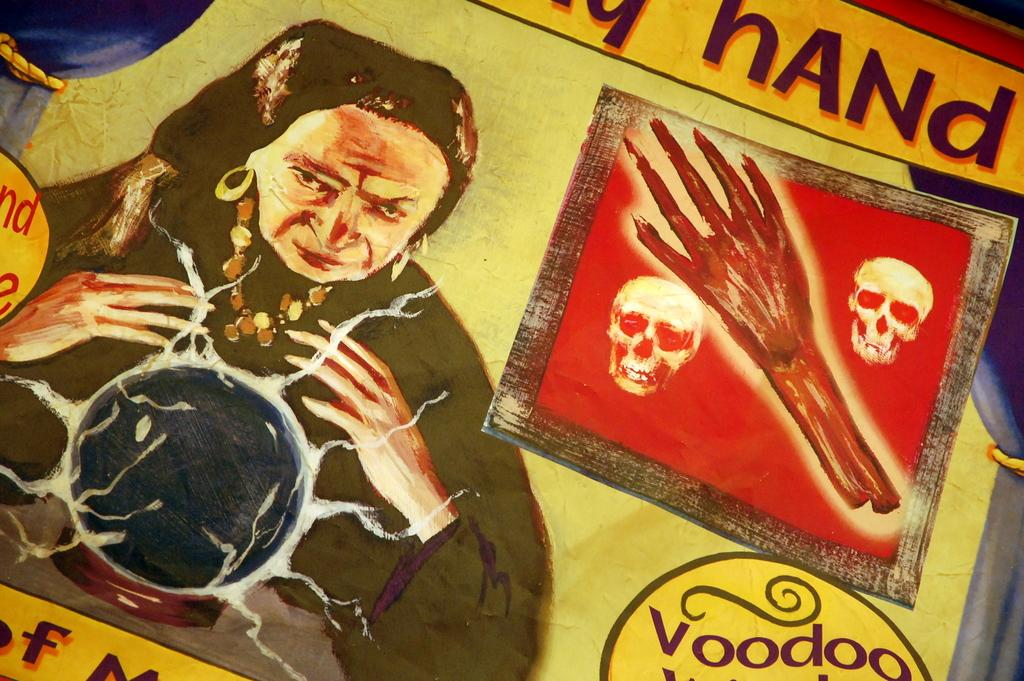What type of artwork is depicted in the image? The image is a painting. What can be seen on the right side of the painting? There is text and a human hand depicted on the right side of the painting. What objects are present in the painting? Skulls are present in the painting. What figure is on the left side of the painting? There is a woman on the left side of the painting. What type of board game is being played in the scene depicted in the painting? There is no board game present in the painting; it features a woman, text, a human hand, and skulls. How does the painting show respect for the woman on the left side? The painting does not explicitly show respect for the woman; it simply depicts her alongside other elements. 